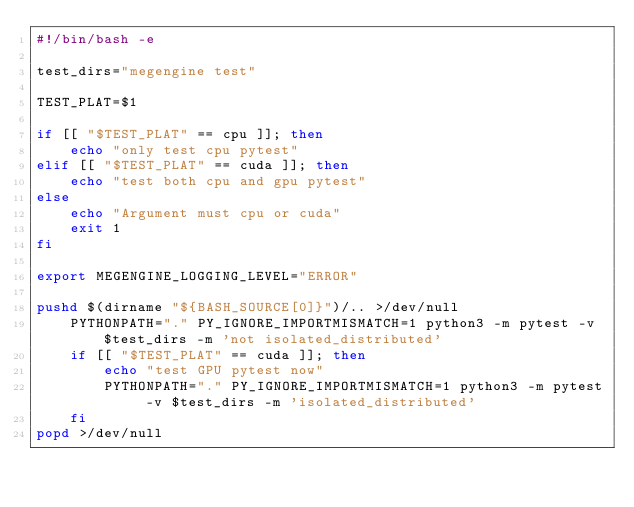Convert code to text. <code><loc_0><loc_0><loc_500><loc_500><_Bash_>#!/bin/bash -e

test_dirs="megengine test"

TEST_PLAT=$1

if [[ "$TEST_PLAT" == cpu ]]; then
    echo "only test cpu pytest"
elif [[ "$TEST_PLAT" == cuda ]]; then
    echo "test both cpu and gpu pytest"
else
    echo "Argument must cpu or cuda"
    exit 1
fi

export MEGENGINE_LOGGING_LEVEL="ERROR"

pushd $(dirname "${BASH_SOURCE[0]}")/.. >/dev/null
    PYTHONPATH="." PY_IGNORE_IMPORTMISMATCH=1 python3 -m pytest -v $test_dirs -m 'not isolated_distributed'
    if [[ "$TEST_PLAT" == cuda ]]; then
        echo "test GPU pytest now"
        PYTHONPATH="." PY_IGNORE_IMPORTMISMATCH=1 python3 -m pytest -v $test_dirs -m 'isolated_distributed'
    fi
popd >/dev/null
</code> 